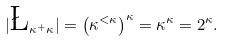<formula> <loc_0><loc_0><loc_500><loc_500>| \L _ { \kappa ^ { + } \kappa } | = \left ( \kappa ^ { < \kappa } \right ) ^ { \kappa } = \kappa ^ { \kappa } = 2 ^ { \kappa } .</formula> 